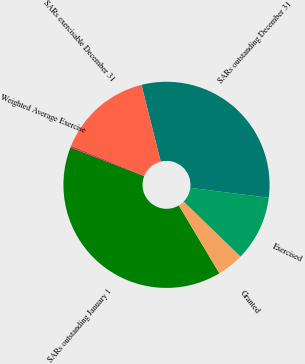Convert chart to OTSL. <chart><loc_0><loc_0><loc_500><loc_500><pie_chart><fcel>SARs outstanding January 1<fcel>Granted<fcel>Exercised<fcel>SARs outstanding December 31<fcel>SARs exercisable December 31<fcel>Weighted Average Exercise<nl><fcel>39.5%<fcel>4.19%<fcel>10.24%<fcel>30.91%<fcel>14.9%<fcel>0.27%<nl></chart> 